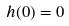<formula> <loc_0><loc_0><loc_500><loc_500>h ( 0 ) = 0</formula> 